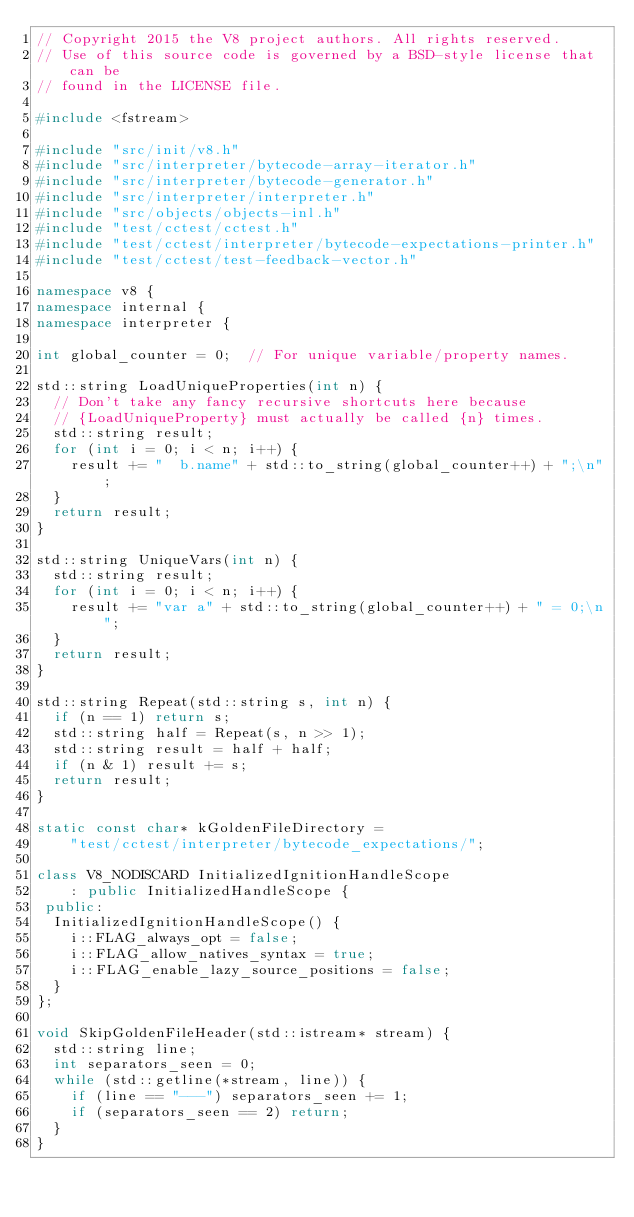Convert code to text. <code><loc_0><loc_0><loc_500><loc_500><_C++_>// Copyright 2015 the V8 project authors. All rights reserved.
// Use of this source code is governed by a BSD-style license that can be
// found in the LICENSE file.

#include <fstream>

#include "src/init/v8.h"
#include "src/interpreter/bytecode-array-iterator.h"
#include "src/interpreter/bytecode-generator.h"
#include "src/interpreter/interpreter.h"
#include "src/objects/objects-inl.h"
#include "test/cctest/cctest.h"
#include "test/cctest/interpreter/bytecode-expectations-printer.h"
#include "test/cctest/test-feedback-vector.h"

namespace v8 {
namespace internal {
namespace interpreter {

int global_counter = 0;  // For unique variable/property names.

std::string LoadUniqueProperties(int n) {
  // Don't take any fancy recursive shortcuts here because
  // {LoadUniqueProperty} must actually be called {n} times.
  std::string result;
  for (int i = 0; i < n; i++) {
    result += "  b.name" + std::to_string(global_counter++) + ";\n";
  }
  return result;
}

std::string UniqueVars(int n) {
  std::string result;
  for (int i = 0; i < n; i++) {
    result += "var a" + std::to_string(global_counter++) + " = 0;\n";
  }
  return result;
}

std::string Repeat(std::string s, int n) {
  if (n == 1) return s;
  std::string half = Repeat(s, n >> 1);
  std::string result = half + half;
  if (n & 1) result += s;
  return result;
}

static const char* kGoldenFileDirectory =
    "test/cctest/interpreter/bytecode_expectations/";

class V8_NODISCARD InitializedIgnitionHandleScope
    : public InitializedHandleScope {
 public:
  InitializedIgnitionHandleScope() {
    i::FLAG_always_opt = false;
    i::FLAG_allow_natives_syntax = true;
    i::FLAG_enable_lazy_source_positions = false;
  }
};

void SkipGoldenFileHeader(std::istream* stream) {
  std::string line;
  int separators_seen = 0;
  while (std::getline(*stream, line)) {
    if (line == "---") separators_seen += 1;
    if (separators_seen == 2) return;
  }
}
</code> 